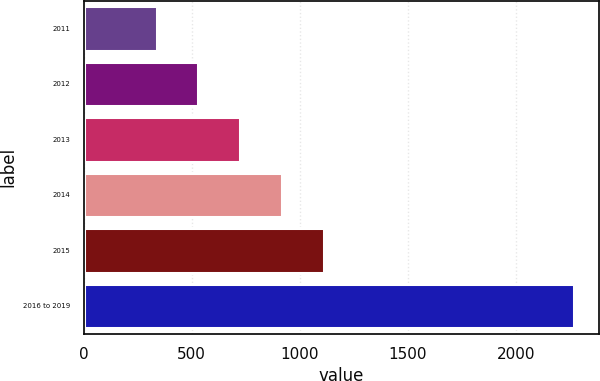<chart> <loc_0><loc_0><loc_500><loc_500><bar_chart><fcel>2011<fcel>2012<fcel>2013<fcel>2014<fcel>2015<fcel>2016 to 2019<nl><fcel>337<fcel>530.4<fcel>723.8<fcel>917.2<fcel>1110.6<fcel>2271<nl></chart> 